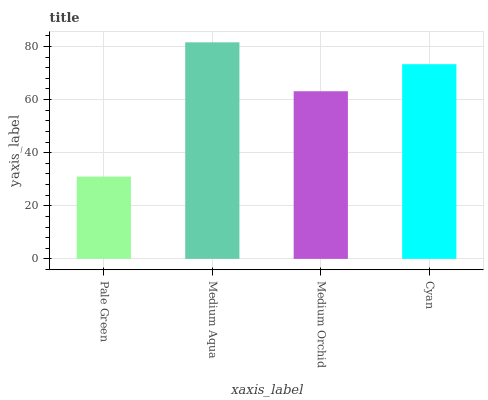Is Pale Green the minimum?
Answer yes or no. Yes. Is Medium Aqua the maximum?
Answer yes or no. Yes. Is Medium Orchid the minimum?
Answer yes or no. No. Is Medium Orchid the maximum?
Answer yes or no. No. Is Medium Aqua greater than Medium Orchid?
Answer yes or no. Yes. Is Medium Orchid less than Medium Aqua?
Answer yes or no. Yes. Is Medium Orchid greater than Medium Aqua?
Answer yes or no. No. Is Medium Aqua less than Medium Orchid?
Answer yes or no. No. Is Cyan the high median?
Answer yes or no. Yes. Is Medium Orchid the low median?
Answer yes or no. Yes. Is Medium Orchid the high median?
Answer yes or no. No. Is Medium Aqua the low median?
Answer yes or no. No. 